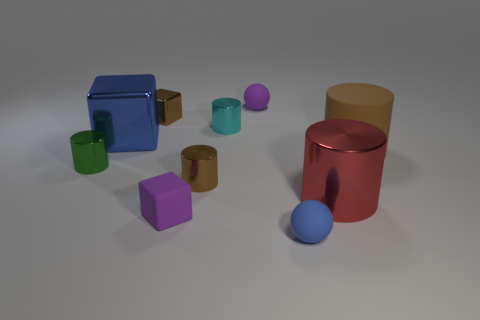Subtract all brown cylinders. How many were subtracted if there are1brown cylinders left? 1 Subtract all red cylinders. How many cylinders are left? 4 Subtract all cyan metallic cylinders. How many cylinders are left? 4 Subtract all yellow cylinders. Subtract all yellow blocks. How many cylinders are left? 5 Subtract all blocks. How many objects are left? 7 Add 3 big metal cylinders. How many big metal cylinders exist? 4 Subtract 1 green cylinders. How many objects are left? 9 Subtract all purple rubber blocks. Subtract all large blue spheres. How many objects are left? 9 Add 6 blocks. How many blocks are left? 9 